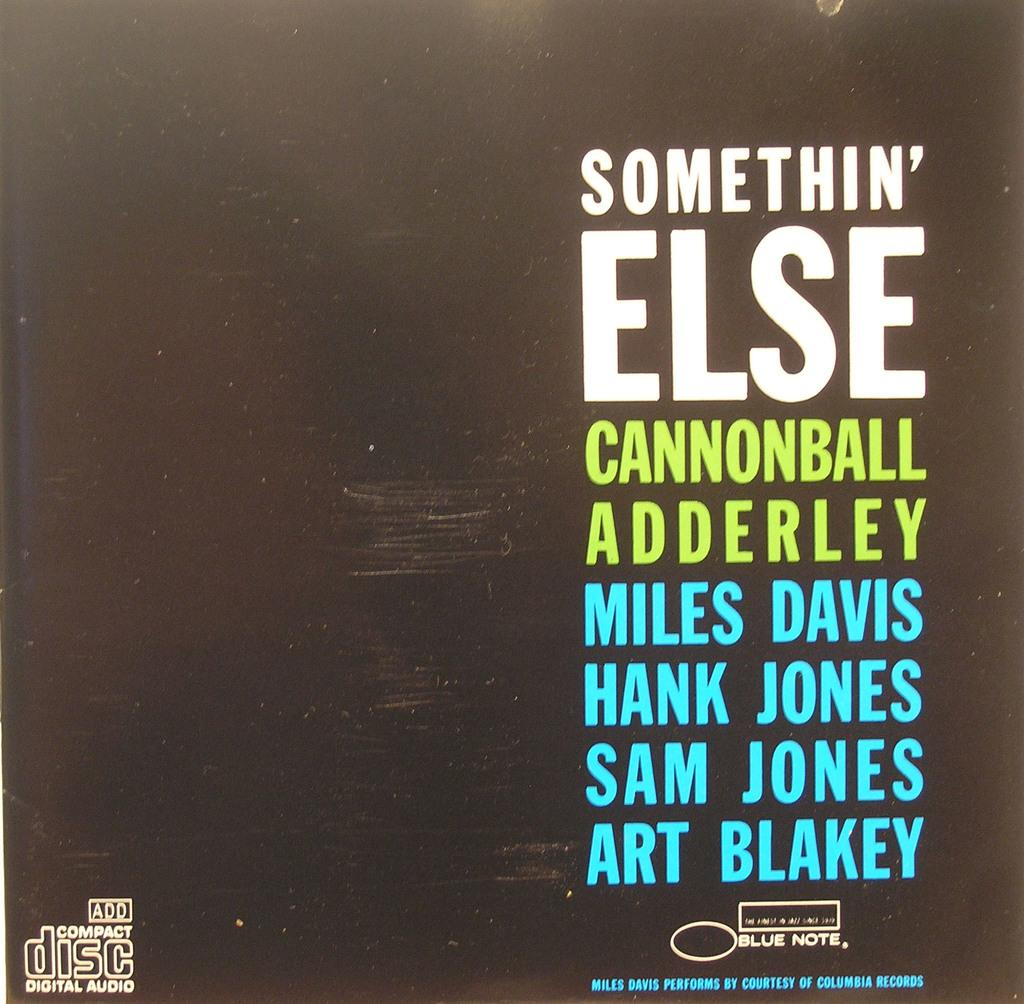<image>
Relay a brief, clear account of the picture shown. A cover art for Somethin' Else by Cannonball Adderley is shown. 